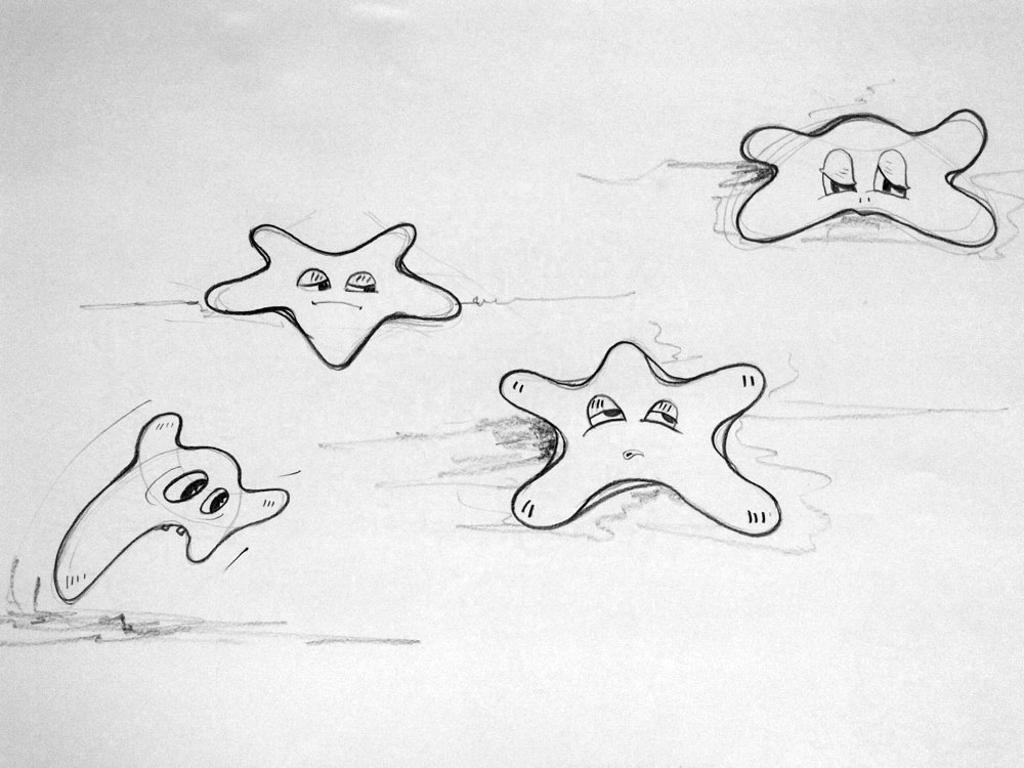What is the color of the paper in the image? The paper in the image is white. What is depicted on the paper? There are drawings of cartoons on the paper. What advice does the army give on the paper in the image? There is no mention of the army or any advice in the image; it only features drawings of cartoons on a white paper. 